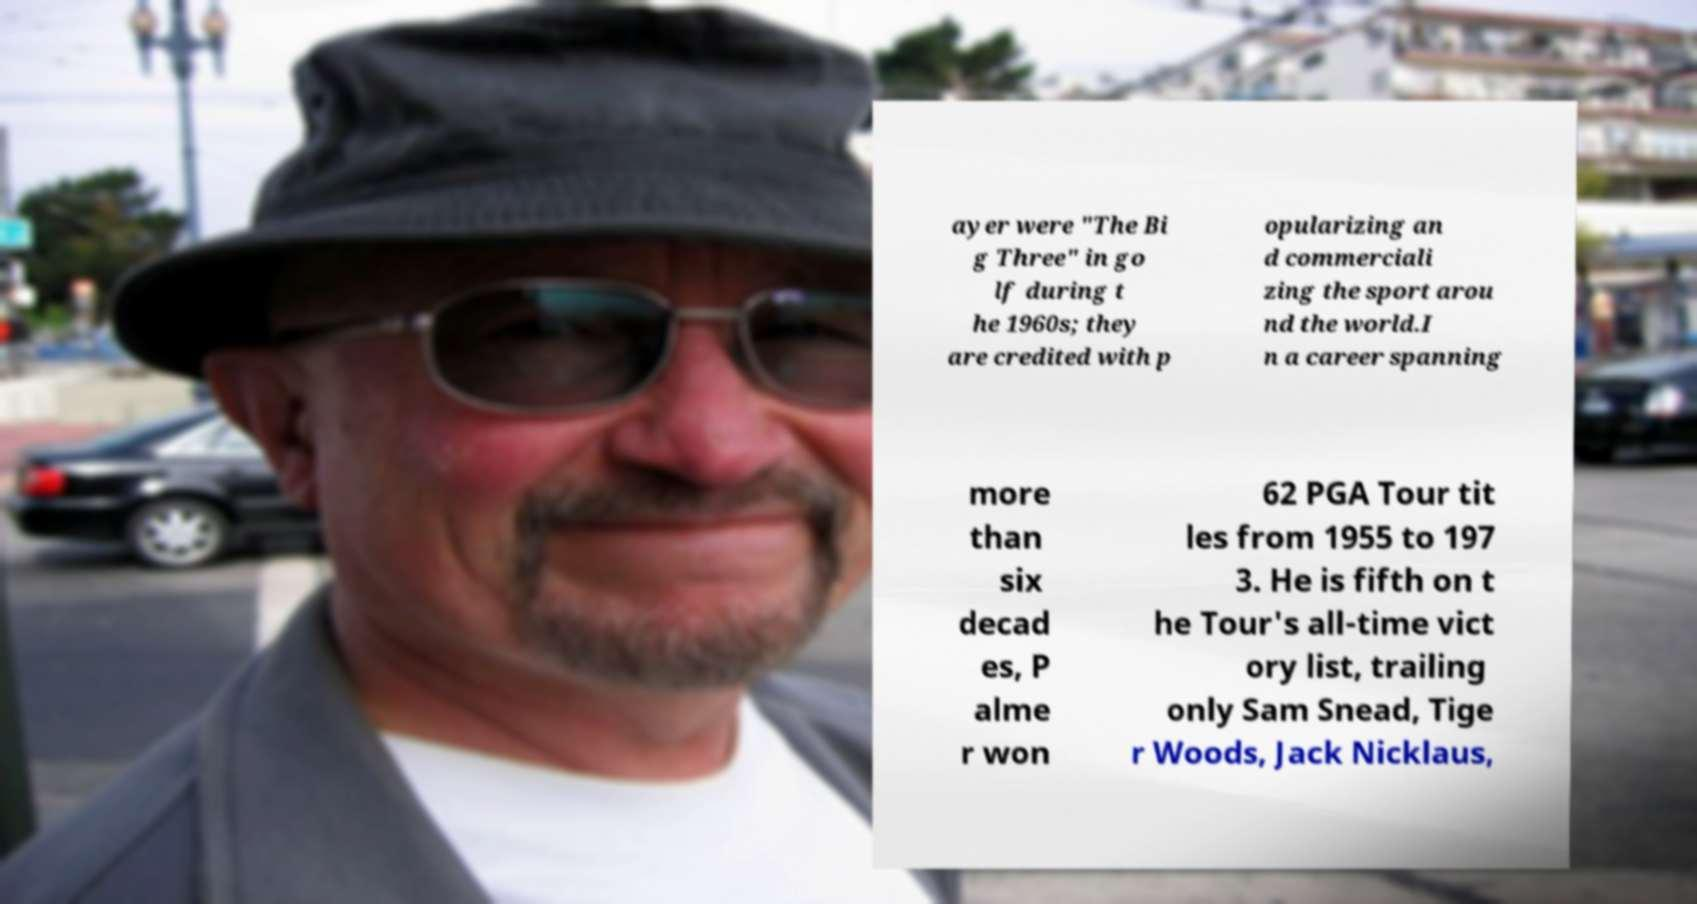Could you extract and type out the text from this image? ayer were "The Bi g Three" in go lf during t he 1960s; they are credited with p opularizing an d commerciali zing the sport arou nd the world.I n a career spanning more than six decad es, P alme r won 62 PGA Tour tit les from 1955 to 197 3. He is fifth on t he Tour's all-time vict ory list, trailing only Sam Snead, Tige r Woods, Jack Nicklaus, 